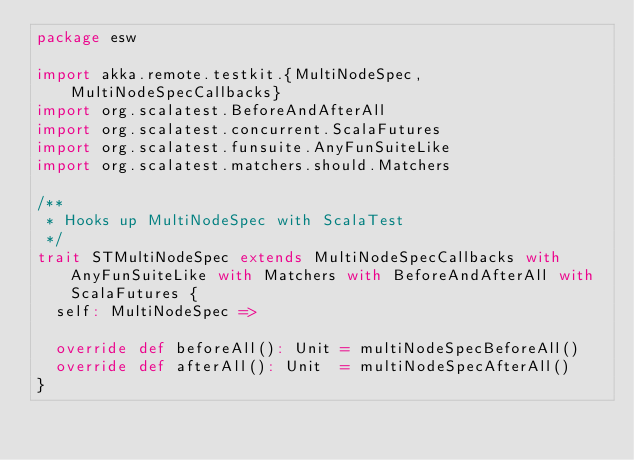<code> <loc_0><loc_0><loc_500><loc_500><_Scala_>package esw

import akka.remote.testkit.{MultiNodeSpec, MultiNodeSpecCallbacks}
import org.scalatest.BeforeAndAfterAll
import org.scalatest.concurrent.ScalaFutures
import org.scalatest.funsuite.AnyFunSuiteLike
import org.scalatest.matchers.should.Matchers

/**
 * Hooks up MultiNodeSpec with ScalaTest
 */
trait STMultiNodeSpec extends MultiNodeSpecCallbacks with AnyFunSuiteLike with Matchers with BeforeAndAfterAll with ScalaFutures {
  self: MultiNodeSpec =>

  override def beforeAll(): Unit = multiNodeSpecBeforeAll()
  override def afterAll(): Unit  = multiNodeSpecAfterAll()
}
</code> 